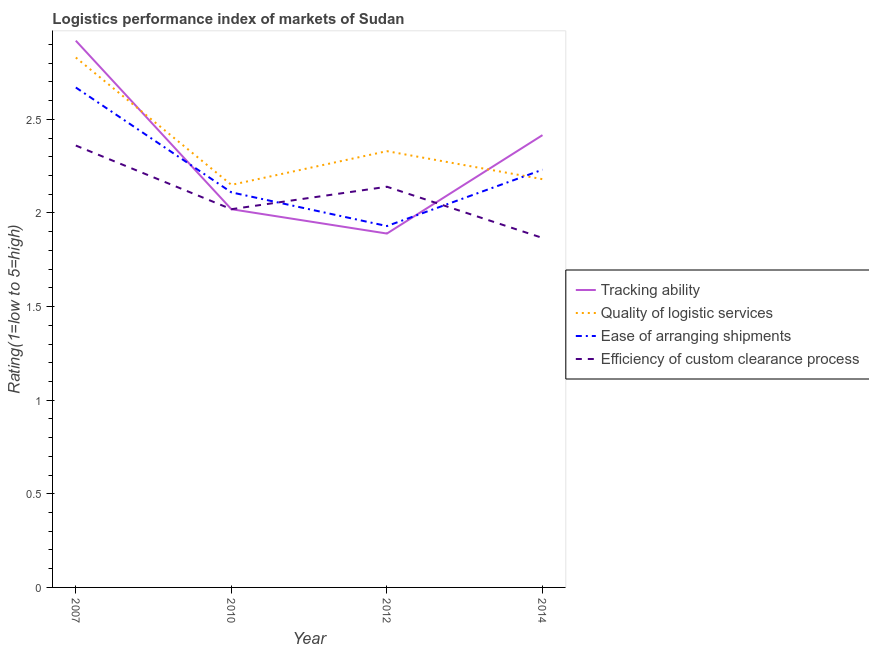Does the line corresponding to lpi rating of efficiency of custom clearance process intersect with the line corresponding to lpi rating of tracking ability?
Your answer should be very brief. Yes. What is the lpi rating of efficiency of custom clearance process in 2007?
Make the answer very short. 2.36. Across all years, what is the maximum lpi rating of efficiency of custom clearance process?
Keep it short and to the point. 2.36. Across all years, what is the minimum lpi rating of ease of arranging shipments?
Provide a short and direct response. 1.93. In which year was the lpi rating of quality of logistic services maximum?
Provide a succinct answer. 2007. In which year was the lpi rating of ease of arranging shipments minimum?
Provide a succinct answer. 2012. What is the total lpi rating of efficiency of custom clearance process in the graph?
Your response must be concise. 8.39. What is the difference between the lpi rating of tracking ability in 2010 and that in 2014?
Make the answer very short. -0.4. What is the difference between the lpi rating of efficiency of custom clearance process in 2014 and the lpi rating of tracking ability in 2010?
Your answer should be very brief. -0.15. What is the average lpi rating of ease of arranging shipments per year?
Your response must be concise. 2.24. In the year 2010, what is the difference between the lpi rating of tracking ability and lpi rating of quality of logistic services?
Your response must be concise. -0.13. In how many years, is the lpi rating of quality of logistic services greater than 1.9?
Give a very brief answer. 4. What is the ratio of the lpi rating of quality of logistic services in 2010 to that in 2012?
Ensure brevity in your answer.  0.92. Is the lpi rating of efficiency of custom clearance process in 2010 less than that in 2014?
Your response must be concise. No. Is the difference between the lpi rating of efficiency of custom clearance process in 2007 and 2012 greater than the difference between the lpi rating of quality of logistic services in 2007 and 2012?
Keep it short and to the point. No. What is the difference between the highest and the second highest lpi rating of ease of arranging shipments?
Ensure brevity in your answer.  0.44. What is the difference between the highest and the lowest lpi rating of efficiency of custom clearance process?
Your answer should be compact. 0.49. In how many years, is the lpi rating of tracking ability greater than the average lpi rating of tracking ability taken over all years?
Ensure brevity in your answer.  2. Does the lpi rating of quality of logistic services monotonically increase over the years?
Give a very brief answer. No. Is the lpi rating of quality of logistic services strictly greater than the lpi rating of tracking ability over the years?
Give a very brief answer. No. Is the lpi rating of efficiency of custom clearance process strictly less than the lpi rating of ease of arranging shipments over the years?
Provide a short and direct response. No. How many lines are there?
Ensure brevity in your answer.  4. How many years are there in the graph?
Give a very brief answer. 4. What is the difference between two consecutive major ticks on the Y-axis?
Provide a short and direct response. 0.5. Are the values on the major ticks of Y-axis written in scientific E-notation?
Keep it short and to the point. No. Does the graph contain grids?
Your response must be concise. No. Where does the legend appear in the graph?
Ensure brevity in your answer.  Center right. How are the legend labels stacked?
Your answer should be compact. Vertical. What is the title of the graph?
Ensure brevity in your answer.  Logistics performance index of markets of Sudan. Does "Other Minerals" appear as one of the legend labels in the graph?
Ensure brevity in your answer.  No. What is the label or title of the X-axis?
Provide a short and direct response. Year. What is the label or title of the Y-axis?
Your answer should be very brief. Rating(1=low to 5=high). What is the Rating(1=low to 5=high) of Tracking ability in 2007?
Offer a very short reply. 2.92. What is the Rating(1=low to 5=high) in Quality of logistic services in 2007?
Give a very brief answer. 2.83. What is the Rating(1=low to 5=high) in Ease of arranging shipments in 2007?
Ensure brevity in your answer.  2.67. What is the Rating(1=low to 5=high) in Efficiency of custom clearance process in 2007?
Your answer should be compact. 2.36. What is the Rating(1=low to 5=high) in Tracking ability in 2010?
Ensure brevity in your answer.  2.02. What is the Rating(1=low to 5=high) in Quality of logistic services in 2010?
Offer a terse response. 2.15. What is the Rating(1=low to 5=high) of Ease of arranging shipments in 2010?
Offer a very short reply. 2.11. What is the Rating(1=low to 5=high) of Efficiency of custom clearance process in 2010?
Make the answer very short. 2.02. What is the Rating(1=low to 5=high) in Tracking ability in 2012?
Your answer should be very brief. 1.89. What is the Rating(1=low to 5=high) of Quality of logistic services in 2012?
Ensure brevity in your answer.  2.33. What is the Rating(1=low to 5=high) in Ease of arranging shipments in 2012?
Make the answer very short. 1.93. What is the Rating(1=low to 5=high) of Efficiency of custom clearance process in 2012?
Keep it short and to the point. 2.14. What is the Rating(1=low to 5=high) of Tracking ability in 2014?
Give a very brief answer. 2.42. What is the Rating(1=low to 5=high) of Quality of logistic services in 2014?
Offer a very short reply. 2.18. What is the Rating(1=low to 5=high) of Ease of arranging shipments in 2014?
Offer a terse response. 2.23. What is the Rating(1=low to 5=high) of Efficiency of custom clearance process in 2014?
Ensure brevity in your answer.  1.87. Across all years, what is the maximum Rating(1=low to 5=high) of Tracking ability?
Offer a terse response. 2.92. Across all years, what is the maximum Rating(1=low to 5=high) of Quality of logistic services?
Make the answer very short. 2.83. Across all years, what is the maximum Rating(1=low to 5=high) of Ease of arranging shipments?
Offer a terse response. 2.67. Across all years, what is the maximum Rating(1=low to 5=high) in Efficiency of custom clearance process?
Your answer should be compact. 2.36. Across all years, what is the minimum Rating(1=low to 5=high) in Tracking ability?
Your answer should be very brief. 1.89. Across all years, what is the minimum Rating(1=low to 5=high) of Quality of logistic services?
Provide a succinct answer. 2.15. Across all years, what is the minimum Rating(1=low to 5=high) in Ease of arranging shipments?
Provide a succinct answer. 1.93. Across all years, what is the minimum Rating(1=low to 5=high) of Efficiency of custom clearance process?
Ensure brevity in your answer.  1.87. What is the total Rating(1=low to 5=high) in Tracking ability in the graph?
Provide a succinct answer. 9.25. What is the total Rating(1=low to 5=high) in Quality of logistic services in the graph?
Give a very brief answer. 9.49. What is the total Rating(1=low to 5=high) of Ease of arranging shipments in the graph?
Offer a terse response. 8.94. What is the total Rating(1=low to 5=high) in Efficiency of custom clearance process in the graph?
Provide a short and direct response. 8.39. What is the difference between the Rating(1=low to 5=high) of Tracking ability in 2007 and that in 2010?
Provide a short and direct response. 0.9. What is the difference between the Rating(1=low to 5=high) in Quality of logistic services in 2007 and that in 2010?
Ensure brevity in your answer.  0.68. What is the difference between the Rating(1=low to 5=high) of Ease of arranging shipments in 2007 and that in 2010?
Provide a succinct answer. 0.56. What is the difference between the Rating(1=low to 5=high) of Efficiency of custom clearance process in 2007 and that in 2010?
Provide a succinct answer. 0.34. What is the difference between the Rating(1=low to 5=high) of Tracking ability in 2007 and that in 2012?
Give a very brief answer. 1.03. What is the difference between the Rating(1=low to 5=high) of Ease of arranging shipments in 2007 and that in 2012?
Make the answer very short. 0.74. What is the difference between the Rating(1=low to 5=high) in Efficiency of custom clearance process in 2007 and that in 2012?
Make the answer very short. 0.22. What is the difference between the Rating(1=low to 5=high) of Tracking ability in 2007 and that in 2014?
Provide a succinct answer. 0.5. What is the difference between the Rating(1=low to 5=high) of Quality of logistic services in 2007 and that in 2014?
Keep it short and to the point. 0.65. What is the difference between the Rating(1=low to 5=high) in Ease of arranging shipments in 2007 and that in 2014?
Provide a succinct answer. 0.44. What is the difference between the Rating(1=low to 5=high) in Efficiency of custom clearance process in 2007 and that in 2014?
Provide a succinct answer. 0.49. What is the difference between the Rating(1=low to 5=high) in Tracking ability in 2010 and that in 2012?
Your response must be concise. 0.13. What is the difference between the Rating(1=low to 5=high) of Quality of logistic services in 2010 and that in 2012?
Keep it short and to the point. -0.18. What is the difference between the Rating(1=low to 5=high) of Ease of arranging shipments in 2010 and that in 2012?
Offer a very short reply. 0.18. What is the difference between the Rating(1=low to 5=high) of Efficiency of custom clearance process in 2010 and that in 2012?
Your response must be concise. -0.12. What is the difference between the Rating(1=low to 5=high) of Tracking ability in 2010 and that in 2014?
Make the answer very short. -0.4. What is the difference between the Rating(1=low to 5=high) in Quality of logistic services in 2010 and that in 2014?
Give a very brief answer. -0.03. What is the difference between the Rating(1=low to 5=high) of Ease of arranging shipments in 2010 and that in 2014?
Keep it short and to the point. -0.12. What is the difference between the Rating(1=low to 5=high) in Efficiency of custom clearance process in 2010 and that in 2014?
Offer a very short reply. 0.15. What is the difference between the Rating(1=low to 5=high) in Tracking ability in 2012 and that in 2014?
Ensure brevity in your answer.  -0.53. What is the difference between the Rating(1=low to 5=high) in Quality of logistic services in 2012 and that in 2014?
Your answer should be compact. 0.15. What is the difference between the Rating(1=low to 5=high) in Ease of arranging shipments in 2012 and that in 2014?
Ensure brevity in your answer.  -0.3. What is the difference between the Rating(1=low to 5=high) in Efficiency of custom clearance process in 2012 and that in 2014?
Ensure brevity in your answer.  0.27. What is the difference between the Rating(1=low to 5=high) in Tracking ability in 2007 and the Rating(1=low to 5=high) in Quality of logistic services in 2010?
Your answer should be very brief. 0.77. What is the difference between the Rating(1=low to 5=high) of Tracking ability in 2007 and the Rating(1=low to 5=high) of Ease of arranging shipments in 2010?
Your answer should be compact. 0.81. What is the difference between the Rating(1=low to 5=high) of Tracking ability in 2007 and the Rating(1=low to 5=high) of Efficiency of custom clearance process in 2010?
Offer a terse response. 0.9. What is the difference between the Rating(1=low to 5=high) of Quality of logistic services in 2007 and the Rating(1=low to 5=high) of Ease of arranging shipments in 2010?
Offer a very short reply. 0.72. What is the difference between the Rating(1=low to 5=high) in Quality of logistic services in 2007 and the Rating(1=low to 5=high) in Efficiency of custom clearance process in 2010?
Give a very brief answer. 0.81. What is the difference between the Rating(1=low to 5=high) of Ease of arranging shipments in 2007 and the Rating(1=low to 5=high) of Efficiency of custom clearance process in 2010?
Offer a terse response. 0.65. What is the difference between the Rating(1=low to 5=high) in Tracking ability in 2007 and the Rating(1=low to 5=high) in Quality of logistic services in 2012?
Make the answer very short. 0.59. What is the difference between the Rating(1=low to 5=high) in Tracking ability in 2007 and the Rating(1=low to 5=high) in Efficiency of custom clearance process in 2012?
Your answer should be compact. 0.78. What is the difference between the Rating(1=low to 5=high) in Quality of logistic services in 2007 and the Rating(1=low to 5=high) in Ease of arranging shipments in 2012?
Your answer should be compact. 0.9. What is the difference between the Rating(1=low to 5=high) in Quality of logistic services in 2007 and the Rating(1=low to 5=high) in Efficiency of custom clearance process in 2012?
Your answer should be compact. 0.69. What is the difference between the Rating(1=low to 5=high) in Ease of arranging shipments in 2007 and the Rating(1=low to 5=high) in Efficiency of custom clearance process in 2012?
Keep it short and to the point. 0.53. What is the difference between the Rating(1=low to 5=high) in Tracking ability in 2007 and the Rating(1=low to 5=high) in Quality of logistic services in 2014?
Make the answer very short. 0.74. What is the difference between the Rating(1=low to 5=high) in Tracking ability in 2007 and the Rating(1=low to 5=high) in Ease of arranging shipments in 2014?
Make the answer very short. 0.69. What is the difference between the Rating(1=low to 5=high) of Tracking ability in 2007 and the Rating(1=low to 5=high) of Efficiency of custom clearance process in 2014?
Provide a short and direct response. 1.05. What is the difference between the Rating(1=low to 5=high) in Quality of logistic services in 2007 and the Rating(1=low to 5=high) in Ease of arranging shipments in 2014?
Your answer should be very brief. 0.6. What is the difference between the Rating(1=low to 5=high) of Quality of logistic services in 2007 and the Rating(1=low to 5=high) of Efficiency of custom clearance process in 2014?
Provide a succinct answer. 0.96. What is the difference between the Rating(1=low to 5=high) in Ease of arranging shipments in 2007 and the Rating(1=low to 5=high) in Efficiency of custom clearance process in 2014?
Your answer should be compact. 0.8. What is the difference between the Rating(1=low to 5=high) in Tracking ability in 2010 and the Rating(1=low to 5=high) in Quality of logistic services in 2012?
Provide a short and direct response. -0.31. What is the difference between the Rating(1=low to 5=high) in Tracking ability in 2010 and the Rating(1=low to 5=high) in Ease of arranging shipments in 2012?
Make the answer very short. 0.09. What is the difference between the Rating(1=low to 5=high) in Tracking ability in 2010 and the Rating(1=low to 5=high) in Efficiency of custom clearance process in 2012?
Provide a succinct answer. -0.12. What is the difference between the Rating(1=low to 5=high) in Quality of logistic services in 2010 and the Rating(1=low to 5=high) in Ease of arranging shipments in 2012?
Provide a short and direct response. 0.22. What is the difference between the Rating(1=low to 5=high) in Quality of logistic services in 2010 and the Rating(1=low to 5=high) in Efficiency of custom clearance process in 2012?
Provide a short and direct response. 0.01. What is the difference between the Rating(1=low to 5=high) of Ease of arranging shipments in 2010 and the Rating(1=low to 5=high) of Efficiency of custom clearance process in 2012?
Make the answer very short. -0.03. What is the difference between the Rating(1=low to 5=high) of Tracking ability in 2010 and the Rating(1=low to 5=high) of Quality of logistic services in 2014?
Make the answer very short. -0.16. What is the difference between the Rating(1=low to 5=high) of Tracking ability in 2010 and the Rating(1=low to 5=high) of Ease of arranging shipments in 2014?
Your response must be concise. -0.21. What is the difference between the Rating(1=low to 5=high) of Tracking ability in 2010 and the Rating(1=low to 5=high) of Efficiency of custom clearance process in 2014?
Provide a succinct answer. 0.15. What is the difference between the Rating(1=low to 5=high) in Quality of logistic services in 2010 and the Rating(1=low to 5=high) in Ease of arranging shipments in 2014?
Keep it short and to the point. -0.08. What is the difference between the Rating(1=low to 5=high) in Quality of logistic services in 2010 and the Rating(1=low to 5=high) in Efficiency of custom clearance process in 2014?
Make the answer very short. 0.28. What is the difference between the Rating(1=low to 5=high) of Ease of arranging shipments in 2010 and the Rating(1=low to 5=high) of Efficiency of custom clearance process in 2014?
Your answer should be compact. 0.24. What is the difference between the Rating(1=low to 5=high) of Tracking ability in 2012 and the Rating(1=low to 5=high) of Quality of logistic services in 2014?
Make the answer very short. -0.29. What is the difference between the Rating(1=low to 5=high) in Tracking ability in 2012 and the Rating(1=low to 5=high) in Ease of arranging shipments in 2014?
Offer a terse response. -0.34. What is the difference between the Rating(1=low to 5=high) of Tracking ability in 2012 and the Rating(1=low to 5=high) of Efficiency of custom clearance process in 2014?
Offer a very short reply. 0.02. What is the difference between the Rating(1=low to 5=high) of Quality of logistic services in 2012 and the Rating(1=low to 5=high) of Ease of arranging shipments in 2014?
Provide a short and direct response. 0.1. What is the difference between the Rating(1=low to 5=high) of Quality of logistic services in 2012 and the Rating(1=low to 5=high) of Efficiency of custom clearance process in 2014?
Make the answer very short. 0.46. What is the difference between the Rating(1=low to 5=high) of Ease of arranging shipments in 2012 and the Rating(1=low to 5=high) of Efficiency of custom clearance process in 2014?
Your answer should be very brief. 0.06. What is the average Rating(1=low to 5=high) of Tracking ability per year?
Offer a very short reply. 2.31. What is the average Rating(1=low to 5=high) in Quality of logistic services per year?
Your answer should be very brief. 2.37. What is the average Rating(1=low to 5=high) of Ease of arranging shipments per year?
Ensure brevity in your answer.  2.24. What is the average Rating(1=low to 5=high) of Efficiency of custom clearance process per year?
Offer a very short reply. 2.1. In the year 2007, what is the difference between the Rating(1=low to 5=high) of Tracking ability and Rating(1=low to 5=high) of Quality of logistic services?
Keep it short and to the point. 0.09. In the year 2007, what is the difference between the Rating(1=low to 5=high) of Tracking ability and Rating(1=low to 5=high) of Ease of arranging shipments?
Offer a terse response. 0.25. In the year 2007, what is the difference between the Rating(1=low to 5=high) in Tracking ability and Rating(1=low to 5=high) in Efficiency of custom clearance process?
Your answer should be very brief. 0.56. In the year 2007, what is the difference between the Rating(1=low to 5=high) in Quality of logistic services and Rating(1=low to 5=high) in Ease of arranging shipments?
Provide a succinct answer. 0.16. In the year 2007, what is the difference between the Rating(1=low to 5=high) of Quality of logistic services and Rating(1=low to 5=high) of Efficiency of custom clearance process?
Make the answer very short. 0.47. In the year 2007, what is the difference between the Rating(1=low to 5=high) of Ease of arranging shipments and Rating(1=low to 5=high) of Efficiency of custom clearance process?
Your answer should be compact. 0.31. In the year 2010, what is the difference between the Rating(1=low to 5=high) in Tracking ability and Rating(1=low to 5=high) in Quality of logistic services?
Make the answer very short. -0.13. In the year 2010, what is the difference between the Rating(1=low to 5=high) in Tracking ability and Rating(1=low to 5=high) in Ease of arranging shipments?
Your answer should be very brief. -0.09. In the year 2010, what is the difference between the Rating(1=low to 5=high) of Tracking ability and Rating(1=low to 5=high) of Efficiency of custom clearance process?
Provide a succinct answer. 0. In the year 2010, what is the difference between the Rating(1=low to 5=high) in Quality of logistic services and Rating(1=low to 5=high) in Efficiency of custom clearance process?
Offer a very short reply. 0.13. In the year 2010, what is the difference between the Rating(1=low to 5=high) of Ease of arranging shipments and Rating(1=low to 5=high) of Efficiency of custom clearance process?
Give a very brief answer. 0.09. In the year 2012, what is the difference between the Rating(1=low to 5=high) of Tracking ability and Rating(1=low to 5=high) of Quality of logistic services?
Provide a succinct answer. -0.44. In the year 2012, what is the difference between the Rating(1=low to 5=high) of Tracking ability and Rating(1=low to 5=high) of Ease of arranging shipments?
Keep it short and to the point. -0.04. In the year 2012, what is the difference between the Rating(1=low to 5=high) of Tracking ability and Rating(1=low to 5=high) of Efficiency of custom clearance process?
Make the answer very short. -0.25. In the year 2012, what is the difference between the Rating(1=low to 5=high) of Quality of logistic services and Rating(1=low to 5=high) of Efficiency of custom clearance process?
Your answer should be very brief. 0.19. In the year 2012, what is the difference between the Rating(1=low to 5=high) in Ease of arranging shipments and Rating(1=low to 5=high) in Efficiency of custom clearance process?
Make the answer very short. -0.21. In the year 2014, what is the difference between the Rating(1=low to 5=high) in Tracking ability and Rating(1=low to 5=high) in Quality of logistic services?
Give a very brief answer. 0.24. In the year 2014, what is the difference between the Rating(1=low to 5=high) in Tracking ability and Rating(1=low to 5=high) in Ease of arranging shipments?
Your answer should be compact. 0.18. In the year 2014, what is the difference between the Rating(1=low to 5=high) in Tracking ability and Rating(1=low to 5=high) in Efficiency of custom clearance process?
Offer a terse response. 0.55. In the year 2014, what is the difference between the Rating(1=low to 5=high) of Quality of logistic services and Rating(1=low to 5=high) of Ease of arranging shipments?
Your answer should be compact. -0.05. In the year 2014, what is the difference between the Rating(1=low to 5=high) of Quality of logistic services and Rating(1=low to 5=high) of Efficiency of custom clearance process?
Keep it short and to the point. 0.31. In the year 2014, what is the difference between the Rating(1=low to 5=high) of Ease of arranging shipments and Rating(1=low to 5=high) of Efficiency of custom clearance process?
Provide a short and direct response. 0.36. What is the ratio of the Rating(1=low to 5=high) of Tracking ability in 2007 to that in 2010?
Provide a succinct answer. 1.45. What is the ratio of the Rating(1=low to 5=high) of Quality of logistic services in 2007 to that in 2010?
Offer a very short reply. 1.32. What is the ratio of the Rating(1=low to 5=high) in Ease of arranging shipments in 2007 to that in 2010?
Give a very brief answer. 1.27. What is the ratio of the Rating(1=low to 5=high) in Efficiency of custom clearance process in 2007 to that in 2010?
Give a very brief answer. 1.17. What is the ratio of the Rating(1=low to 5=high) in Tracking ability in 2007 to that in 2012?
Your response must be concise. 1.54. What is the ratio of the Rating(1=low to 5=high) in Quality of logistic services in 2007 to that in 2012?
Your answer should be very brief. 1.21. What is the ratio of the Rating(1=low to 5=high) of Ease of arranging shipments in 2007 to that in 2012?
Keep it short and to the point. 1.38. What is the ratio of the Rating(1=low to 5=high) in Efficiency of custom clearance process in 2007 to that in 2012?
Provide a succinct answer. 1.1. What is the ratio of the Rating(1=low to 5=high) in Tracking ability in 2007 to that in 2014?
Keep it short and to the point. 1.21. What is the ratio of the Rating(1=low to 5=high) in Quality of logistic services in 2007 to that in 2014?
Your response must be concise. 1.3. What is the ratio of the Rating(1=low to 5=high) of Ease of arranging shipments in 2007 to that in 2014?
Offer a very short reply. 1.2. What is the ratio of the Rating(1=low to 5=high) of Efficiency of custom clearance process in 2007 to that in 2014?
Provide a succinct answer. 1.26. What is the ratio of the Rating(1=low to 5=high) in Tracking ability in 2010 to that in 2012?
Ensure brevity in your answer.  1.07. What is the ratio of the Rating(1=low to 5=high) of Quality of logistic services in 2010 to that in 2012?
Your answer should be compact. 0.92. What is the ratio of the Rating(1=low to 5=high) in Ease of arranging shipments in 2010 to that in 2012?
Provide a short and direct response. 1.09. What is the ratio of the Rating(1=low to 5=high) of Efficiency of custom clearance process in 2010 to that in 2012?
Offer a terse response. 0.94. What is the ratio of the Rating(1=low to 5=high) of Tracking ability in 2010 to that in 2014?
Make the answer very short. 0.84. What is the ratio of the Rating(1=low to 5=high) in Quality of logistic services in 2010 to that in 2014?
Make the answer very short. 0.99. What is the ratio of the Rating(1=low to 5=high) in Ease of arranging shipments in 2010 to that in 2014?
Your answer should be very brief. 0.95. What is the ratio of the Rating(1=low to 5=high) of Efficiency of custom clearance process in 2010 to that in 2014?
Offer a very short reply. 1.08. What is the ratio of the Rating(1=low to 5=high) in Tracking ability in 2012 to that in 2014?
Your answer should be compact. 0.78. What is the ratio of the Rating(1=low to 5=high) in Quality of logistic services in 2012 to that in 2014?
Your answer should be compact. 1.07. What is the ratio of the Rating(1=low to 5=high) in Ease of arranging shipments in 2012 to that in 2014?
Your answer should be very brief. 0.87. What is the ratio of the Rating(1=low to 5=high) in Efficiency of custom clearance process in 2012 to that in 2014?
Your answer should be compact. 1.15. What is the difference between the highest and the second highest Rating(1=low to 5=high) in Tracking ability?
Give a very brief answer. 0.5. What is the difference between the highest and the second highest Rating(1=low to 5=high) of Ease of arranging shipments?
Your answer should be compact. 0.44. What is the difference between the highest and the second highest Rating(1=low to 5=high) in Efficiency of custom clearance process?
Keep it short and to the point. 0.22. What is the difference between the highest and the lowest Rating(1=low to 5=high) in Tracking ability?
Offer a very short reply. 1.03. What is the difference between the highest and the lowest Rating(1=low to 5=high) of Quality of logistic services?
Offer a terse response. 0.68. What is the difference between the highest and the lowest Rating(1=low to 5=high) in Ease of arranging shipments?
Keep it short and to the point. 0.74. What is the difference between the highest and the lowest Rating(1=low to 5=high) in Efficiency of custom clearance process?
Offer a terse response. 0.49. 